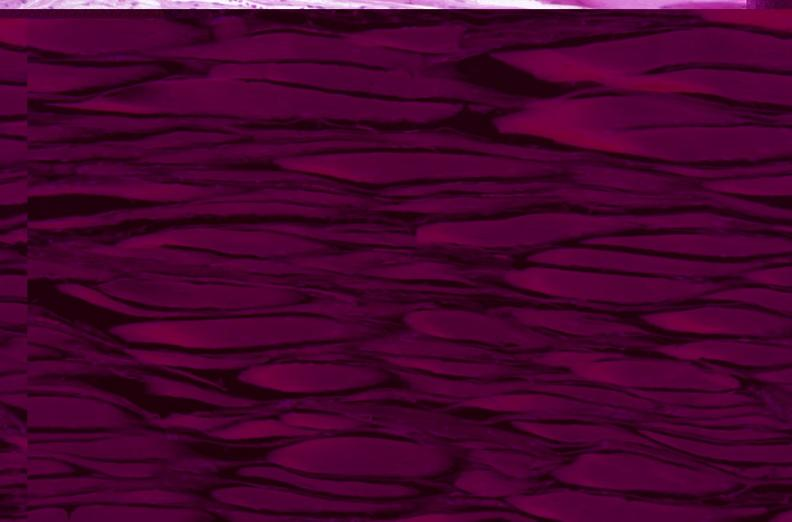what is present?
Answer the question using a single word or phrase. Musculoskeletal 